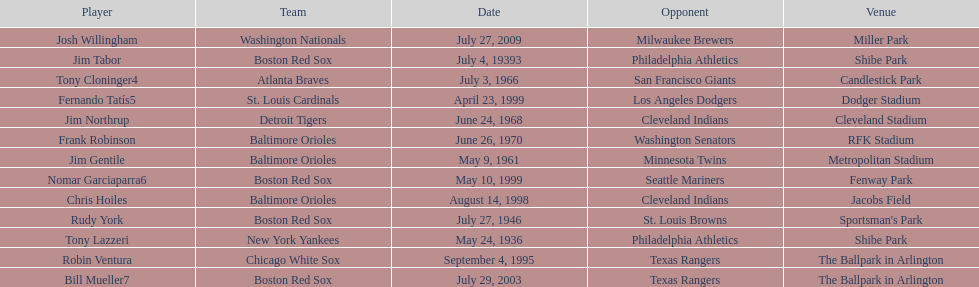What was the name of the player who accomplished this in 1999 but played for the boston red sox? Nomar Garciaparra. 